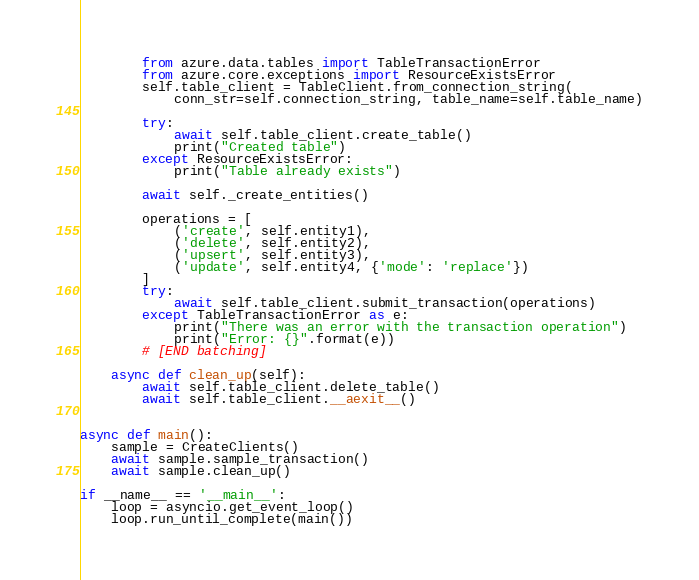Convert code to text. <code><loc_0><loc_0><loc_500><loc_500><_Python_>        from azure.data.tables import TableTransactionError
        from azure.core.exceptions import ResourceExistsError
        self.table_client = TableClient.from_connection_string(
            conn_str=self.connection_string, table_name=self.table_name)

        try:
            await self.table_client.create_table()
            print("Created table")
        except ResourceExistsError:
            print("Table already exists")

        await self._create_entities()

        operations = [
            ('create', self.entity1),
            ('delete', self.entity2),
            ('upsert', self.entity3),
            ('update', self.entity4, {'mode': 'replace'})
        ]
        try:
            await self.table_client.submit_transaction(operations)
        except TableTransactionError as e:
            print("There was an error with the transaction operation")
            print("Error: {}".format(e))
        # [END batching]

    async def clean_up(self):
        await self.table_client.delete_table()
        await self.table_client.__aexit__()


async def main():
    sample = CreateClients()
    await sample.sample_transaction()
    await sample.clean_up()

if __name__ == '__main__':
    loop = asyncio.get_event_loop()
    loop.run_until_complete(main())
</code> 